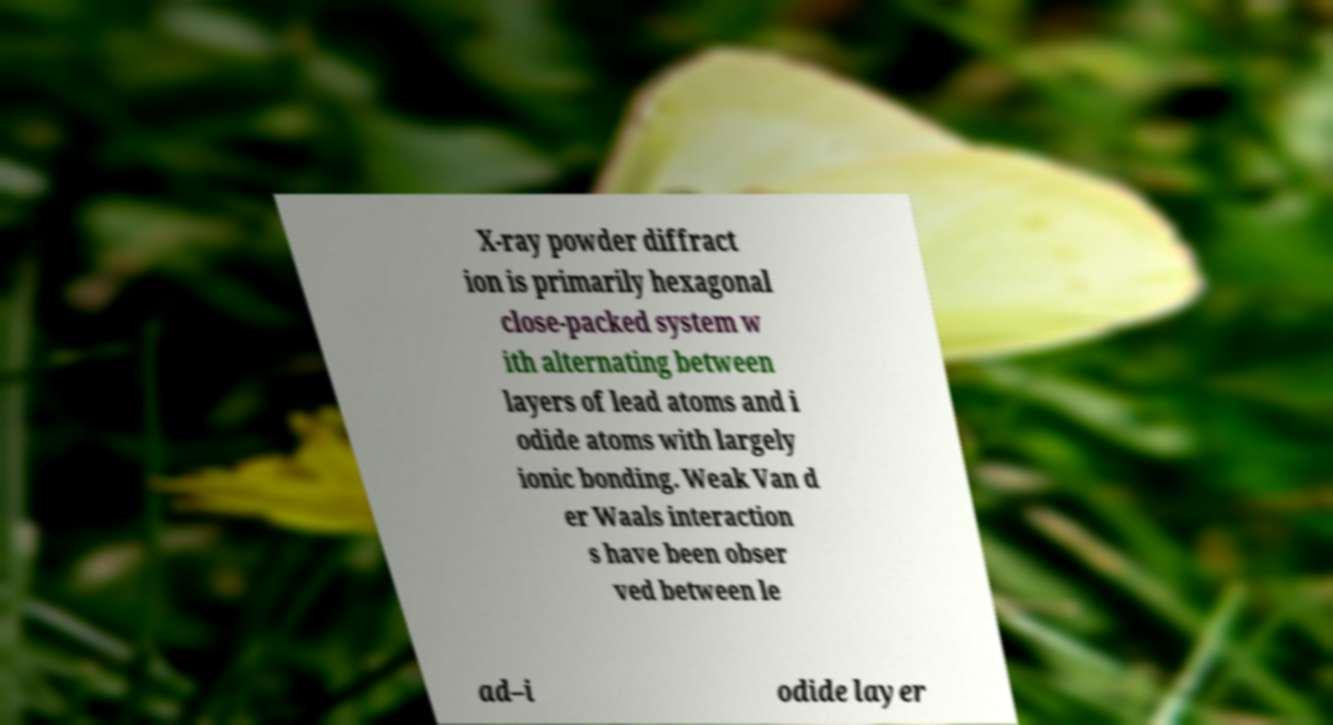There's text embedded in this image that I need extracted. Can you transcribe it verbatim? X-ray powder diffract ion is primarily hexagonal close-packed system w ith alternating between layers of lead atoms and i odide atoms with largely ionic bonding. Weak Van d er Waals interaction s have been obser ved between le ad–i odide layer 